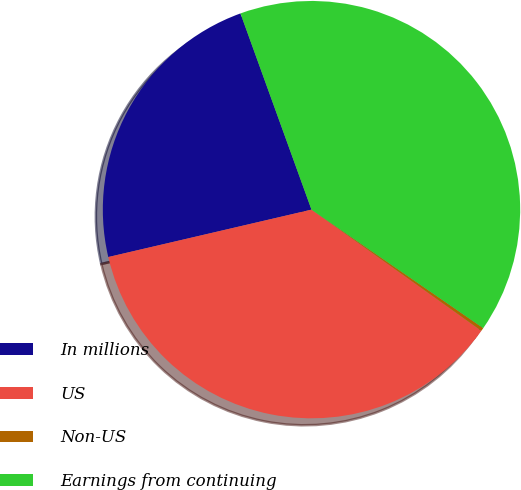Convert chart to OTSL. <chart><loc_0><loc_0><loc_500><loc_500><pie_chart><fcel>In millions<fcel>US<fcel>Non-US<fcel>Earnings from continuing<nl><fcel>23.12%<fcel>36.49%<fcel>0.25%<fcel>40.14%<nl></chart> 